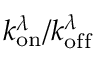Convert formula to latex. <formula><loc_0><loc_0><loc_500><loc_500>k _ { o n } ^ { \lambda } / k _ { o f f } ^ { \lambda }</formula> 